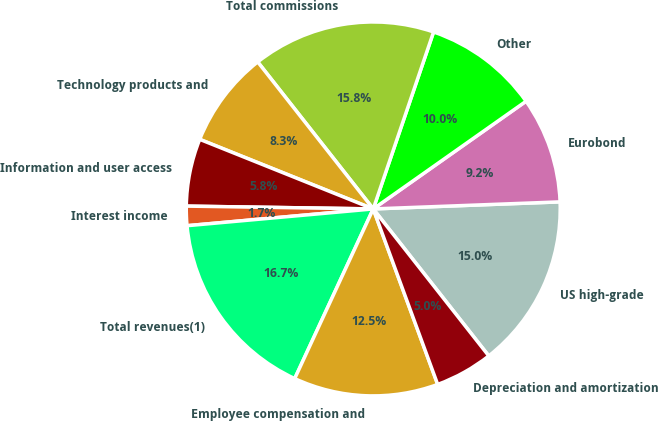<chart> <loc_0><loc_0><loc_500><loc_500><pie_chart><fcel>US high-grade<fcel>Eurobond<fcel>Other<fcel>Total commissions<fcel>Technology products and<fcel>Information and user access<fcel>Interest income<fcel>Total revenues(1)<fcel>Employee compensation and<fcel>Depreciation and amortization<nl><fcel>15.0%<fcel>9.17%<fcel>10.0%<fcel>15.83%<fcel>8.33%<fcel>5.83%<fcel>1.67%<fcel>16.67%<fcel>12.5%<fcel>5.0%<nl></chart> 